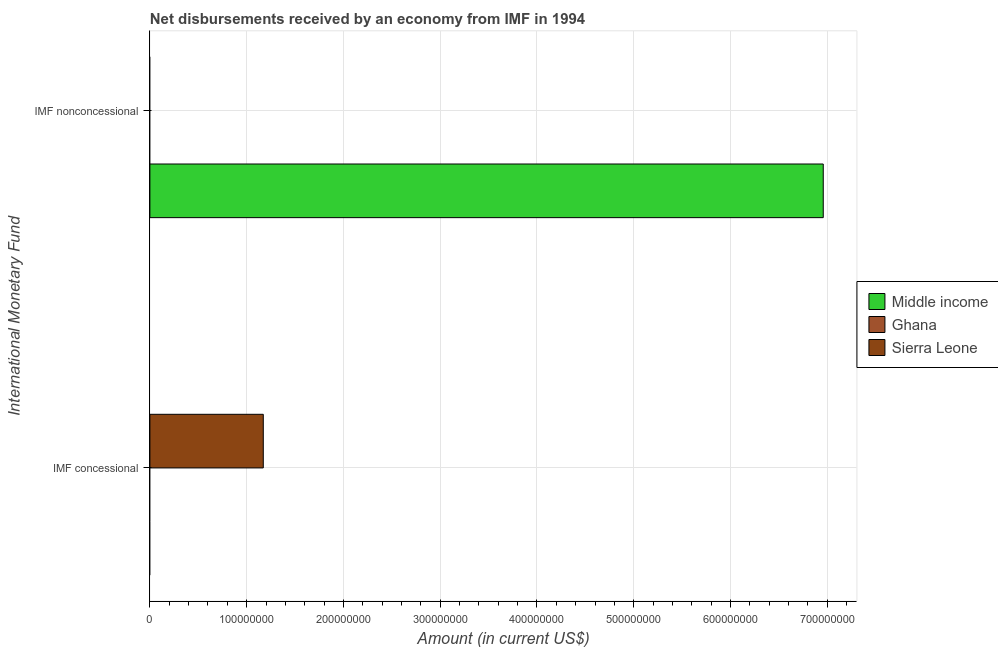How many bars are there on the 2nd tick from the top?
Make the answer very short. 1. How many bars are there on the 1st tick from the bottom?
Ensure brevity in your answer.  1. What is the label of the 1st group of bars from the top?
Provide a short and direct response. IMF nonconcessional. Across all countries, what is the maximum net concessional disbursements from imf?
Your response must be concise. 1.17e+08. Across all countries, what is the minimum net concessional disbursements from imf?
Make the answer very short. 0. What is the total net concessional disbursements from imf in the graph?
Ensure brevity in your answer.  1.17e+08. What is the average net non concessional disbursements from imf per country?
Keep it short and to the point. 2.32e+08. How many countries are there in the graph?
Give a very brief answer. 3. What is the difference between two consecutive major ticks on the X-axis?
Your answer should be compact. 1.00e+08. Where does the legend appear in the graph?
Your response must be concise. Center right. How many legend labels are there?
Give a very brief answer. 3. How are the legend labels stacked?
Make the answer very short. Vertical. What is the title of the graph?
Your answer should be compact. Net disbursements received by an economy from IMF in 1994. Does "Suriname" appear as one of the legend labels in the graph?
Offer a very short reply. No. What is the label or title of the Y-axis?
Your response must be concise. International Monetary Fund. What is the Amount (in current US$) in Ghana in IMF concessional?
Offer a very short reply. 0. What is the Amount (in current US$) in Sierra Leone in IMF concessional?
Provide a succinct answer. 1.17e+08. What is the Amount (in current US$) of Middle income in IMF nonconcessional?
Your answer should be compact. 6.96e+08. Across all International Monetary Fund, what is the maximum Amount (in current US$) in Middle income?
Provide a succinct answer. 6.96e+08. Across all International Monetary Fund, what is the maximum Amount (in current US$) in Sierra Leone?
Provide a short and direct response. 1.17e+08. Across all International Monetary Fund, what is the minimum Amount (in current US$) of Middle income?
Offer a very short reply. 0. Across all International Monetary Fund, what is the minimum Amount (in current US$) in Sierra Leone?
Give a very brief answer. 0. What is the total Amount (in current US$) of Middle income in the graph?
Make the answer very short. 6.96e+08. What is the total Amount (in current US$) of Sierra Leone in the graph?
Make the answer very short. 1.17e+08. What is the average Amount (in current US$) of Middle income per International Monetary Fund?
Your response must be concise. 3.48e+08. What is the average Amount (in current US$) in Sierra Leone per International Monetary Fund?
Your answer should be compact. 5.86e+07. What is the difference between the highest and the lowest Amount (in current US$) in Middle income?
Keep it short and to the point. 6.96e+08. What is the difference between the highest and the lowest Amount (in current US$) in Sierra Leone?
Ensure brevity in your answer.  1.17e+08. 